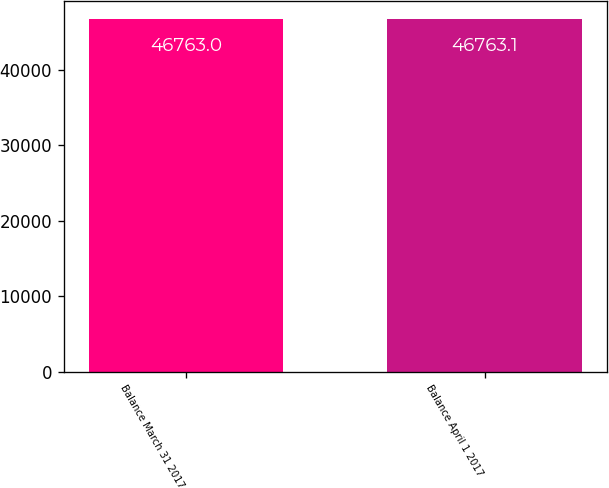Convert chart. <chart><loc_0><loc_0><loc_500><loc_500><bar_chart><fcel>Balance March 31 2017<fcel>Balance April 1 2017<nl><fcel>46763<fcel>46763.1<nl></chart> 